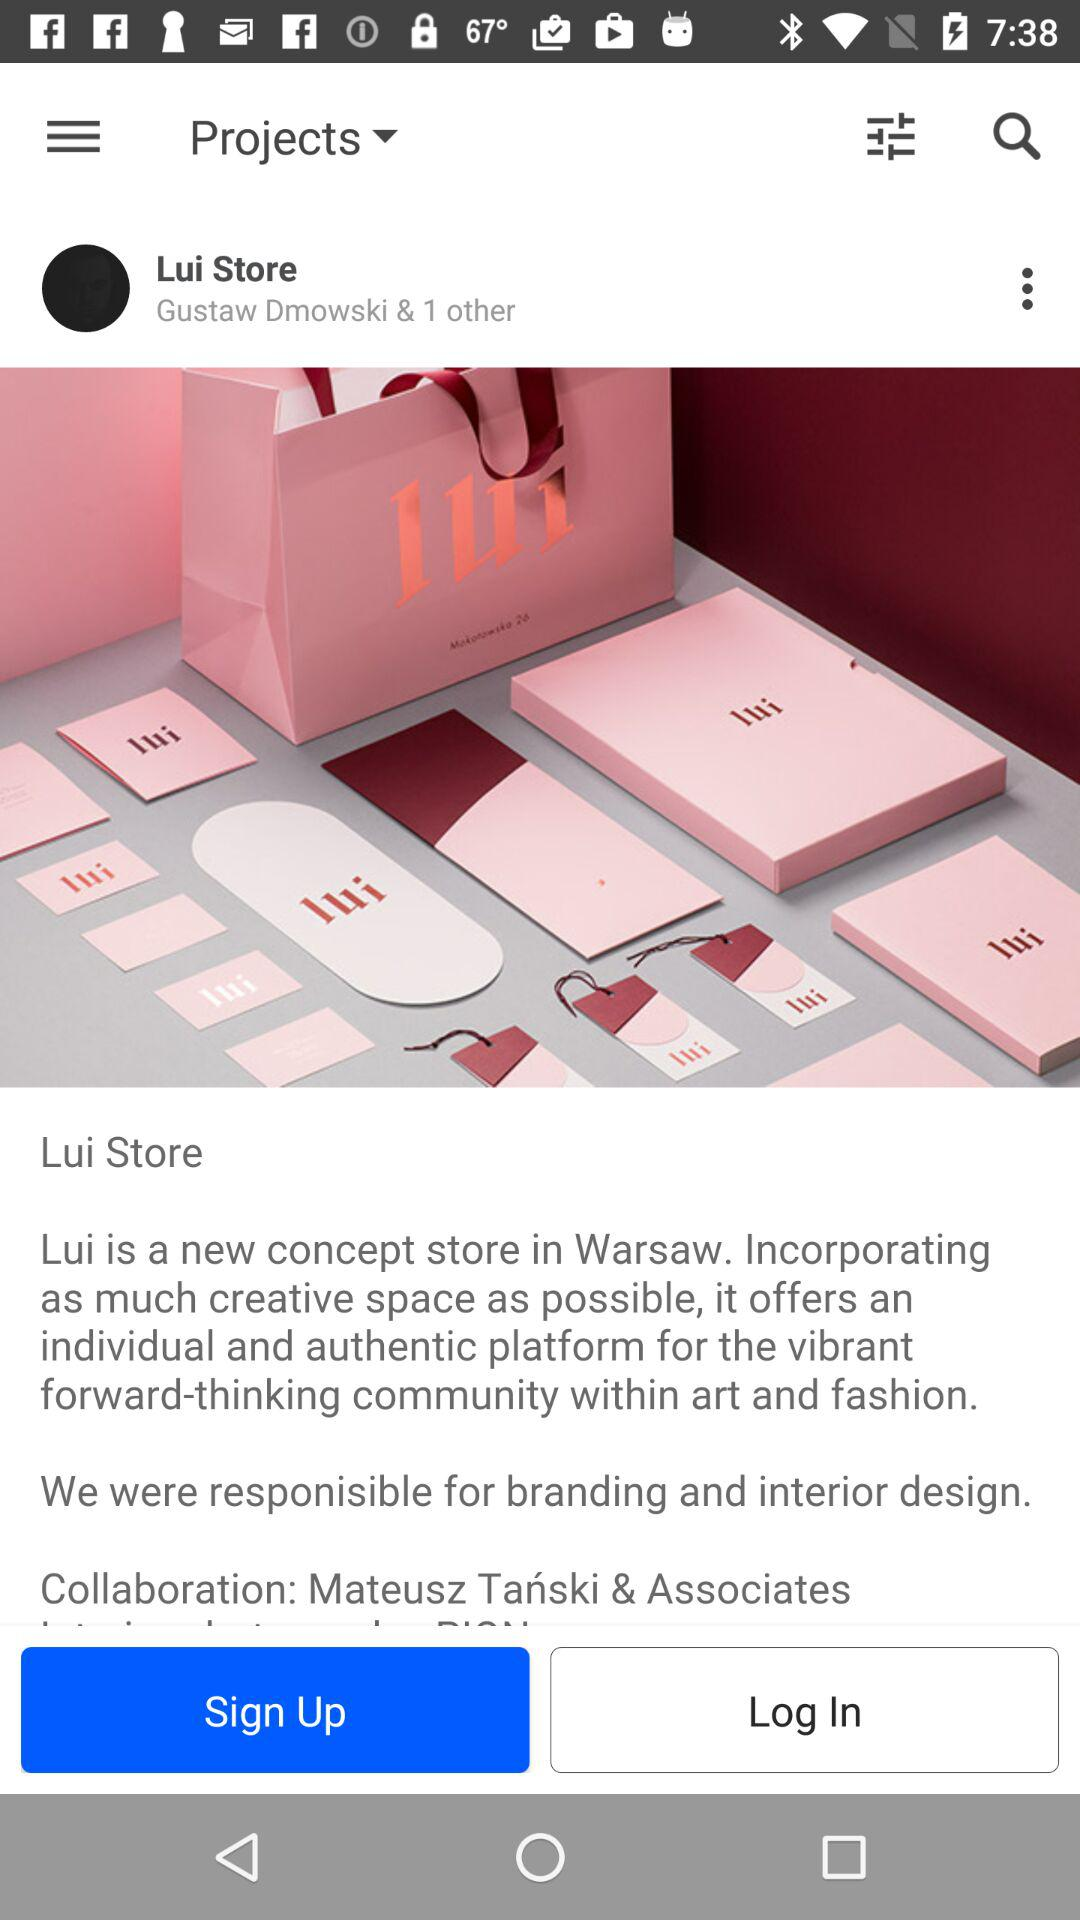What is the Lui Store? The Lui Store is a new concept store. 